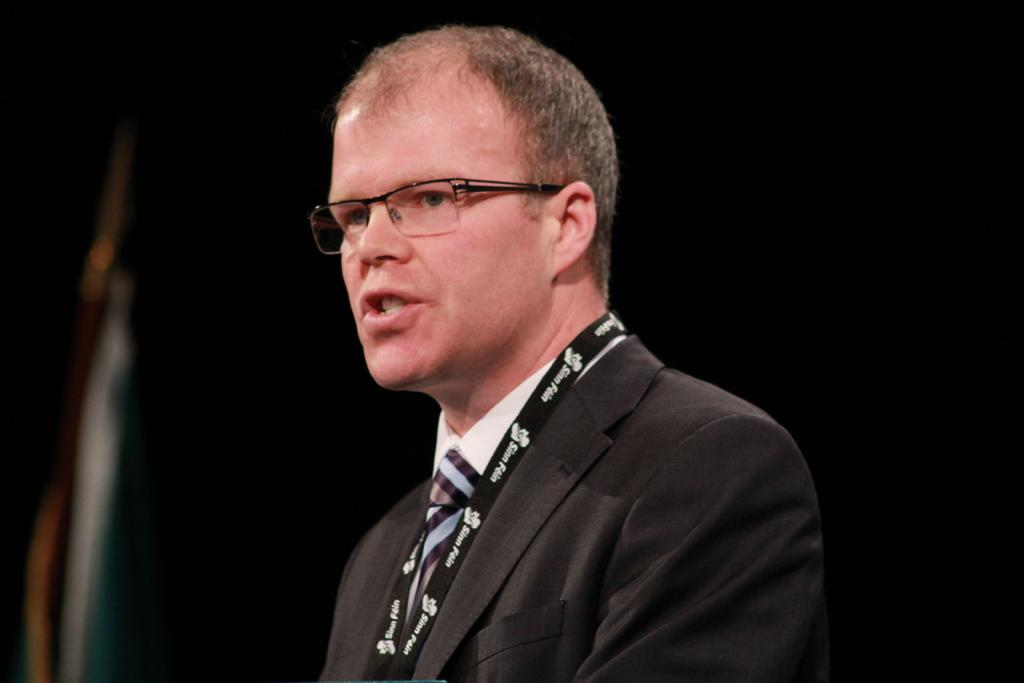Who or what is the main subject of the image? There is a person in the image. What can be observed about the person's appearance? The person is wearing spectacles. What is the color or lighting of the background in the image? The background of the image is dark. What type of pancake is being served on the plate in the image? There is no plate or pancake present in the image; it features a person wearing spectacles against a dark background. How many snakes can be seen slithering in the image? There are no snakes present in the image. 